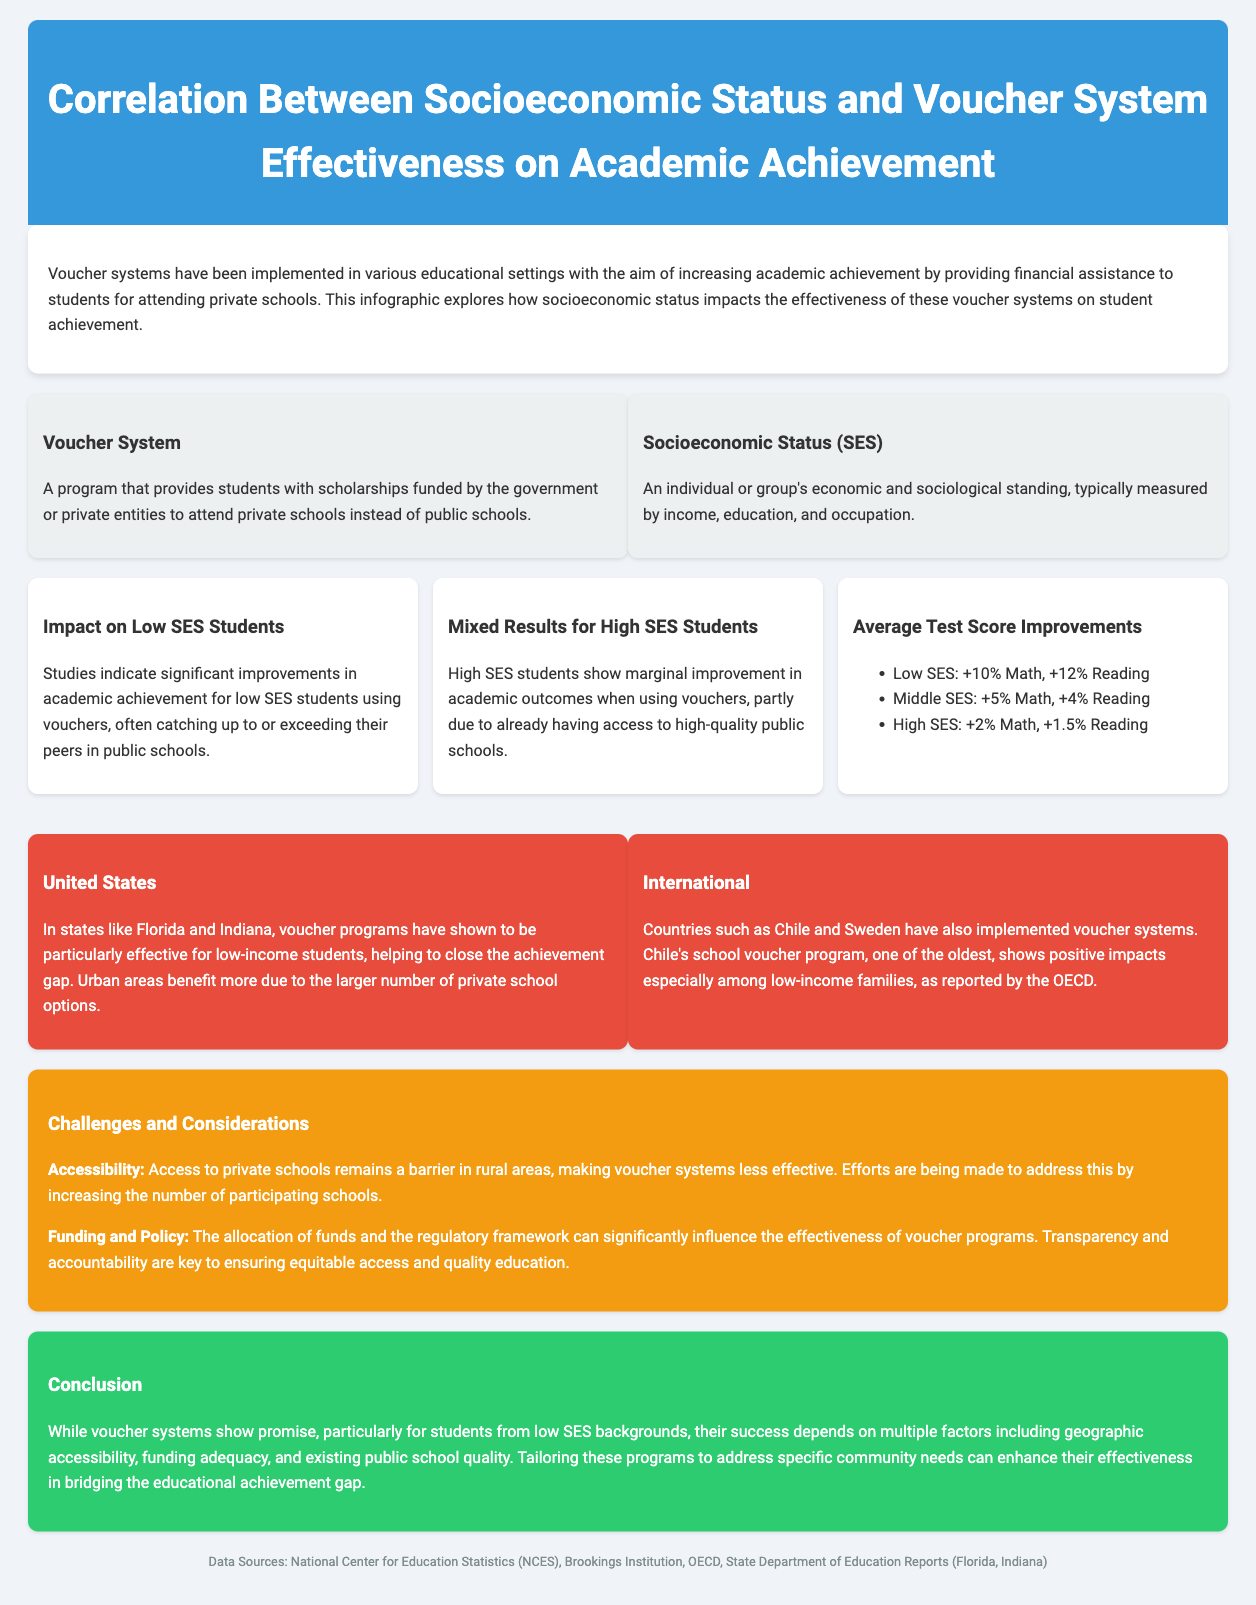What is the title of the infographic? The title is prominently displayed at the top of the document, which summarizes the main focus of the content.
Answer: Correlation Between Socioeconomic Status and Voucher System Effectiveness on Academic Achievement What percentage improvement in Math scores is reported for Low SES students? The document provides specific statistics on average test score improvements by socioeconomic status, particularly highlighting the low SES category.
Answer: +10% Math What challenge is associated with voucher systems in rural areas? The challenges section mentions specific barriers related to geographic location, particularly for rural settings.
Answer: Accessibility Which region shows particularly effective voucher programs for low-income students? The geographical impact of voucher systems is examined in the U.S., and specific states are noted for their effectiveness.
Answer: Florida and Indiana What is a key factor influencing the effectiveness of voucher programs? The document lists several factors that can impact the success of voucher systems, emphasizing the importance of regulation.
Answer: Funding and Policy Which country has implemented one of the oldest voucher systems? The international comparison includes references to specific countries and their experience with voucher systems, focusing on historical context.
Answer: Chile What was the improvement in Reading scores for Middle SES students? The document provides a breakdown of average test score improvements based on socioeconomic status, including specific improvements in Reading.
Answer: +4% Reading What is the source of the data listed at the bottom of the infographic? The document cites specific institutions that provided data used to compile the information presented, which adds credibility to the findings.
Answer: National Center for Education Statistics (NCES), Brookings Institution, OECD, State Department of Education Reports (Florida, Indiana) 